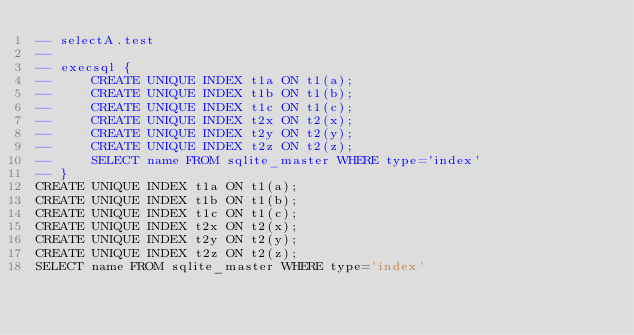<code> <loc_0><loc_0><loc_500><loc_500><_SQL_>-- selectA.test
-- 
-- execsql {
--     CREATE UNIQUE INDEX t1a ON t1(a);
--     CREATE UNIQUE INDEX t1b ON t1(b);
--     CREATE UNIQUE INDEX t1c ON t1(c);
--     CREATE UNIQUE INDEX t2x ON t2(x);
--     CREATE UNIQUE INDEX t2y ON t2(y);
--     CREATE UNIQUE INDEX t2z ON t2(z);
--     SELECT name FROM sqlite_master WHERE type='index'
-- }
CREATE UNIQUE INDEX t1a ON t1(a);
CREATE UNIQUE INDEX t1b ON t1(b);
CREATE UNIQUE INDEX t1c ON t1(c);
CREATE UNIQUE INDEX t2x ON t2(x);
CREATE UNIQUE INDEX t2y ON t2(y);
CREATE UNIQUE INDEX t2z ON t2(z);
SELECT name FROM sqlite_master WHERE type='index'</code> 